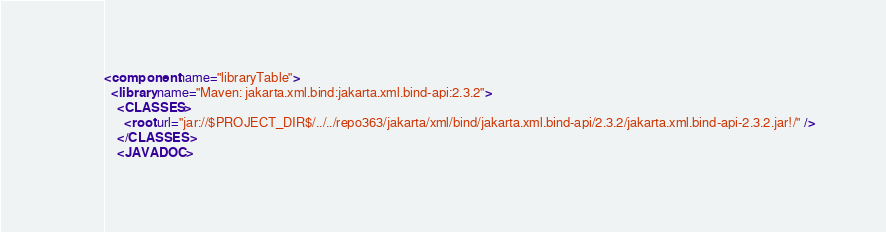Convert code to text. <code><loc_0><loc_0><loc_500><loc_500><_XML_><component name="libraryTable">
  <library name="Maven: jakarta.xml.bind:jakarta.xml.bind-api:2.3.2">
    <CLASSES>
      <root url="jar://$PROJECT_DIR$/../../repo363/jakarta/xml/bind/jakarta.xml.bind-api/2.3.2/jakarta.xml.bind-api-2.3.2.jar!/" />
    </CLASSES>
    <JAVADOC></code> 